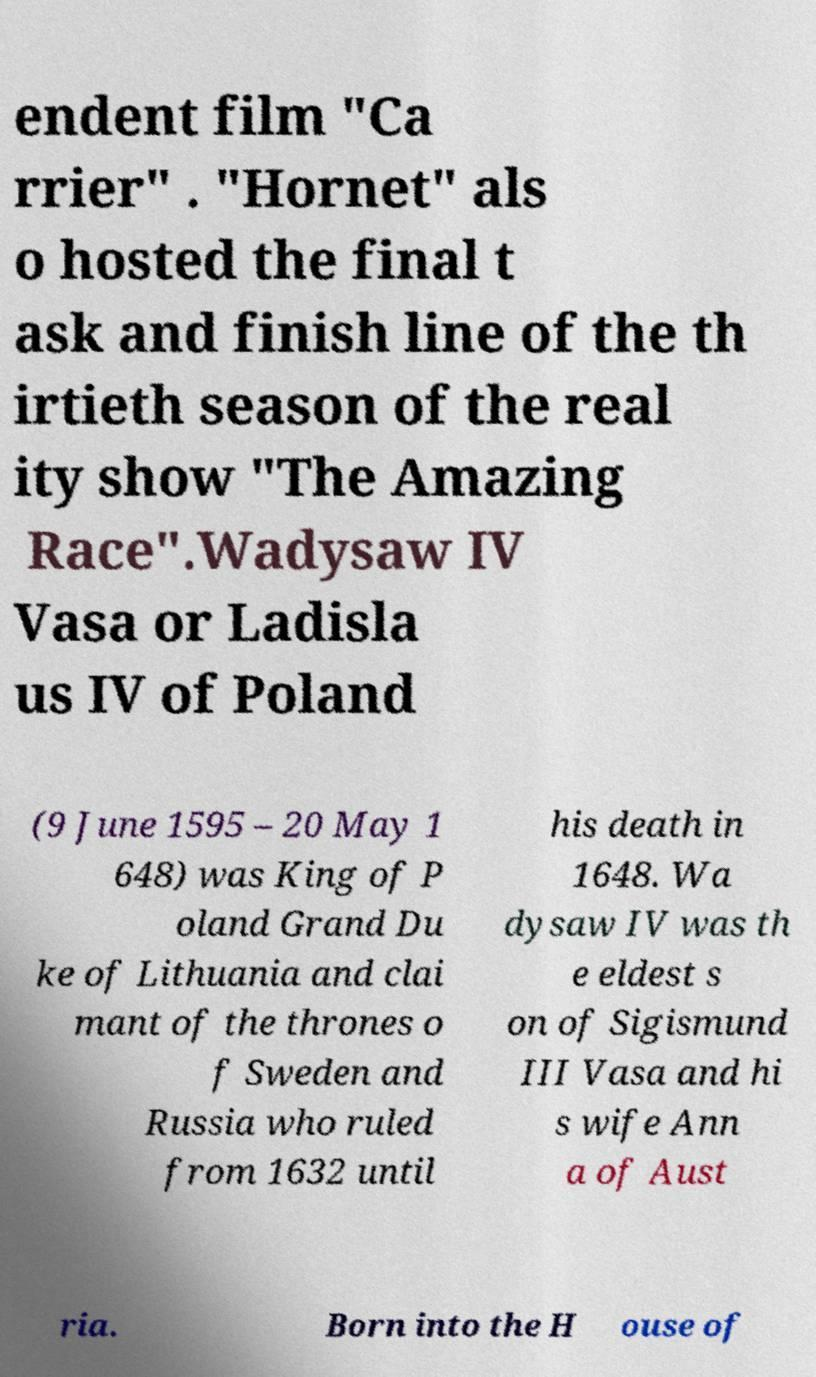I need the written content from this picture converted into text. Can you do that? endent film "Ca rrier" . "Hornet" als o hosted the final t ask and finish line of the th irtieth season of the real ity show "The Amazing Race".Wadysaw IV Vasa or Ladisla us IV of Poland (9 June 1595 – 20 May 1 648) was King of P oland Grand Du ke of Lithuania and clai mant of the thrones o f Sweden and Russia who ruled from 1632 until his death in 1648. Wa dysaw IV was th e eldest s on of Sigismund III Vasa and hi s wife Ann a of Aust ria. Born into the H ouse of 